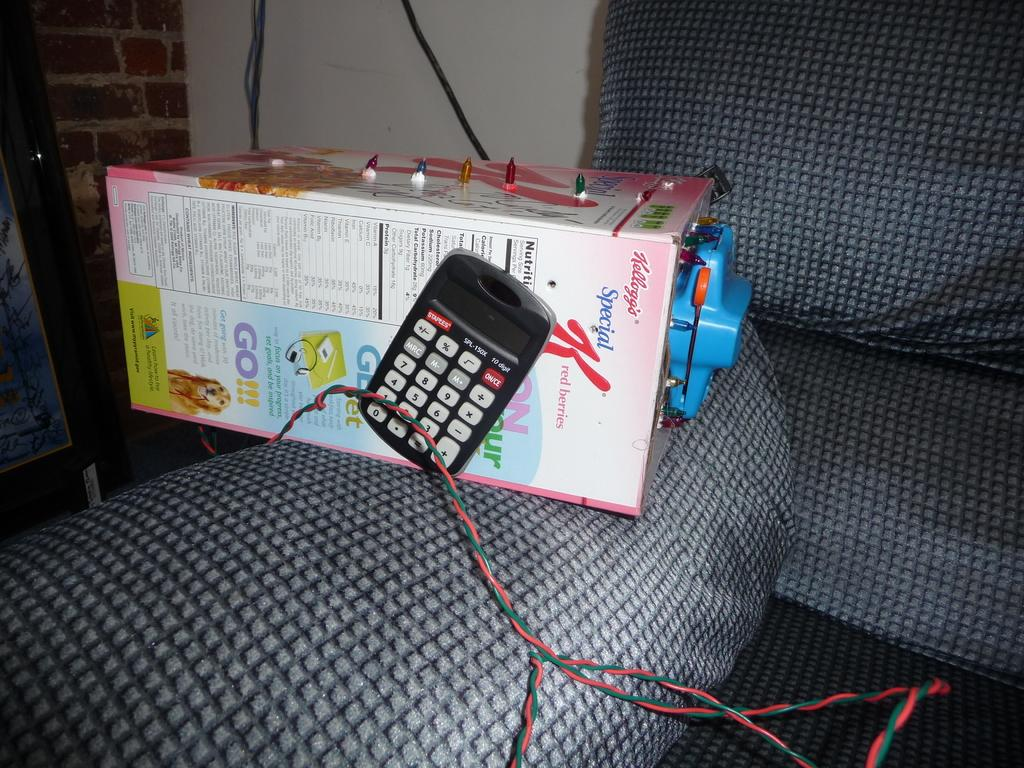<image>
Describe the image concisely. A calculator is on a box of Special K red berries. 